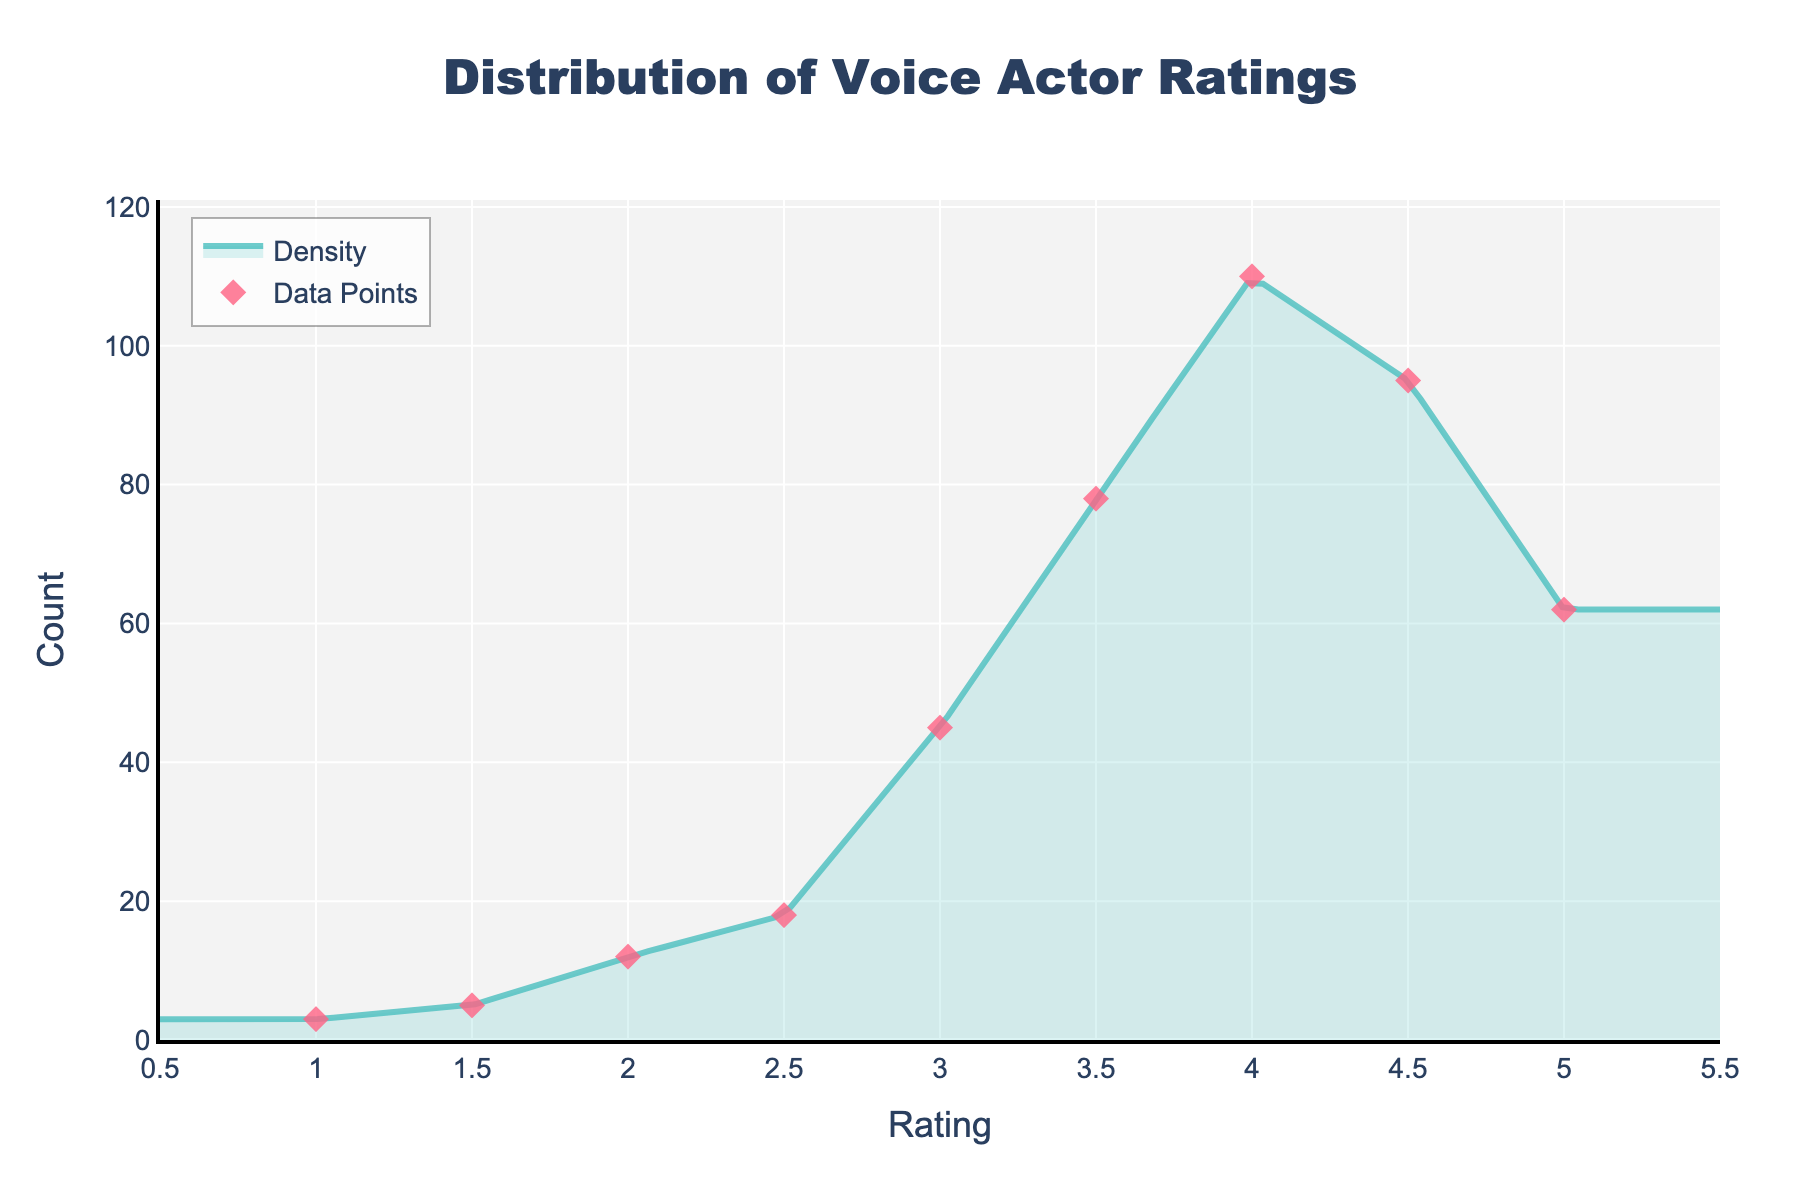What is the title of the figure? The title is always prominently displayed at the top of the figure. In this case, it is "Distribution of Voice Actor Ratings."
Answer: Distribution of Voice Actor Ratings What range of ratings is displayed on the x-axis? The x-axis range is clearly marked with minimum and maximum values. Here, the x-axis ranges from 0.5 to 5.5.
Answer: 0.5 to 5.5 Which rating has the highest count according to the data points? By observing the scatter plot, the highest y-value among the markers corresponds to a rating of 4.0. This is the peak with the count being 110.
Answer: 4.0 How many ratings count are there for the 2.5 rating? Look at the scatter plot and find the data point corresponding to a 2.5 rating. The y-axis value for this point is 18.
Answer: 18 What's the average count of voice actor ratings from 1.0 to 5.0? Add the counts for each rating: 3 + 5 + 12 + 18 + 45 + 78 + 110 + 95 + 62 = 428. There are 9 ratings in total, so the average count is 428 / 9 = 47.56.
Answer: 47.56 How does the count for a 3.5 rating compare to that of a 4.5 rating? Referring to the y-values of the data points, the count for a 3.5 rating is 78, and for a 4.5 rating, it’s 95. Since 95 > 78, the count for a 4.5 rating is higher.
Answer: The count for 4.5 is higher What is the lowest rating with more than 60 counts? Examine the scatter markers to find the ratings with y-values over 60. The lowest rating that meets this criterion is 4.0 with 110 counts.
Answer: 4.0 What is the general trend observed in the density plot from ratings 1.0 to 5.0? The density plot shows a rise in counts as the rating value increases until it peaks around 4.0 and then starts declining. This indicates more voice actors have higher ratings.
Answer: An upward trend followed by a decline How much is the difference in counts between the rating 3.0 and 5.0? The count for rating 3.0 is 45 and for rating 5.0, it is 62. The difference is 62 - 45 = 17.
Answer: 17 Based on the density plot, at which rating(s) does the count first cross 50? The smooth curve of the density plot shows that the count first exceeds 50 between the ratings 3.0 and 3.5.
Answer: Between 3.0 and 3.5 